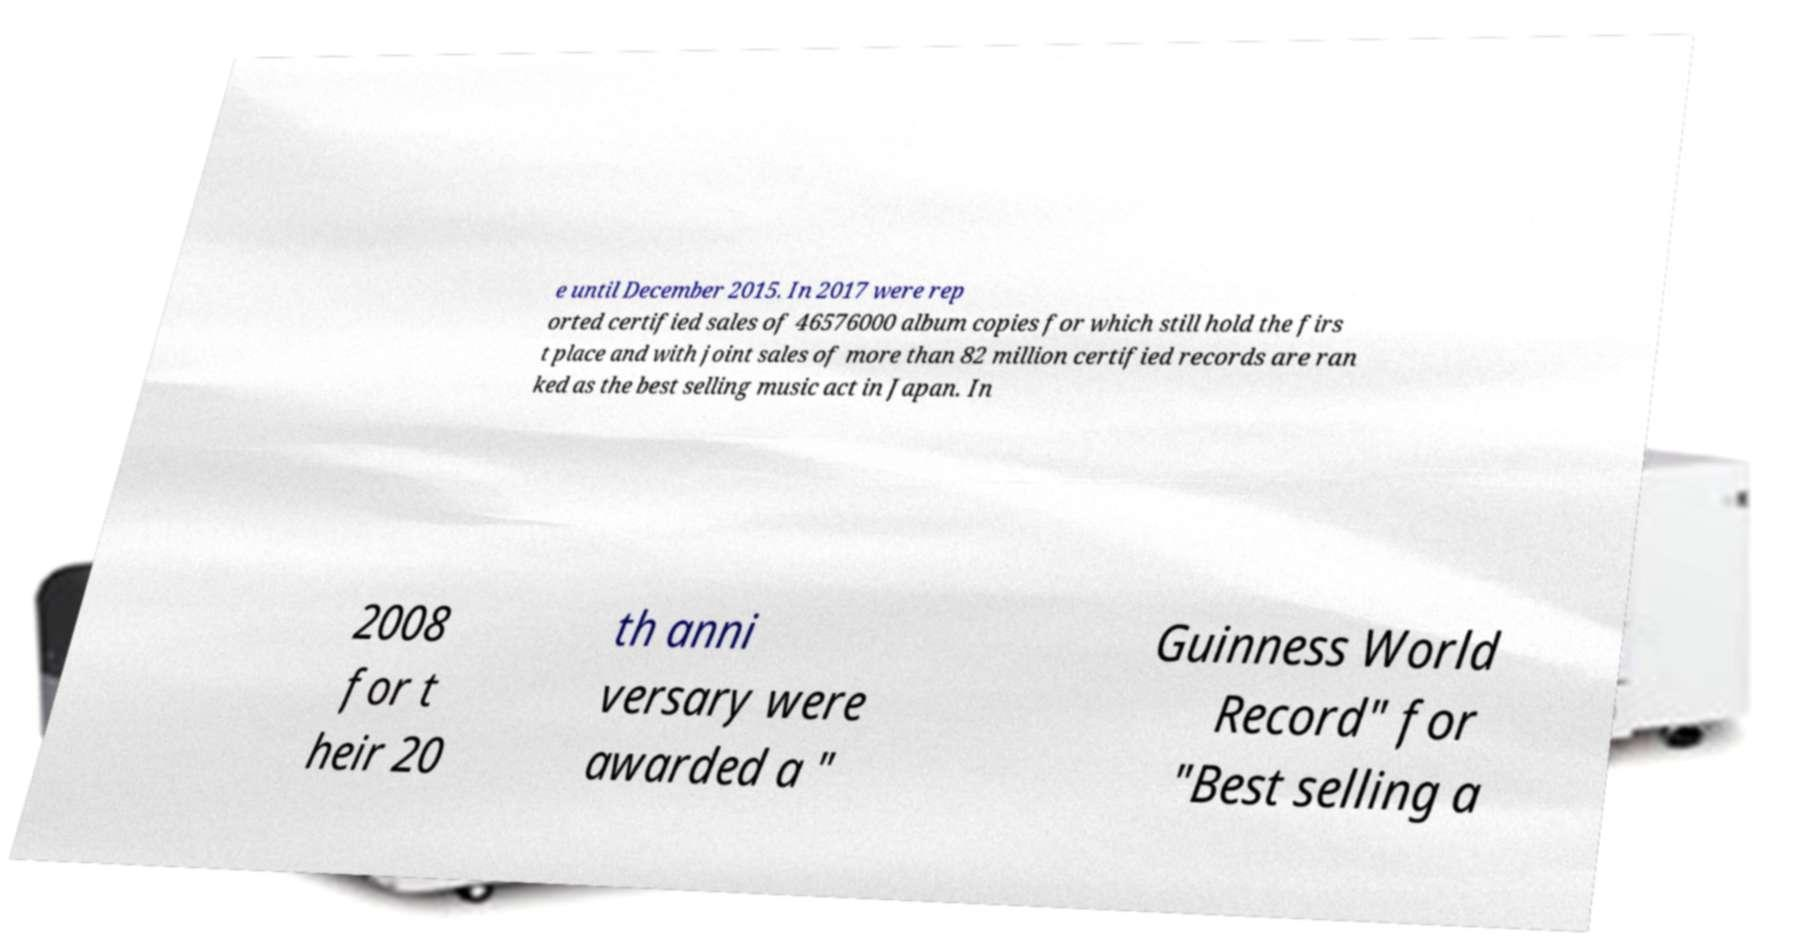Could you assist in decoding the text presented in this image and type it out clearly? e until December 2015. In 2017 were rep orted certified sales of 46576000 album copies for which still hold the firs t place and with joint sales of more than 82 million certified records are ran ked as the best selling music act in Japan. In 2008 for t heir 20 th anni versary were awarded a " Guinness World Record" for "Best selling a 